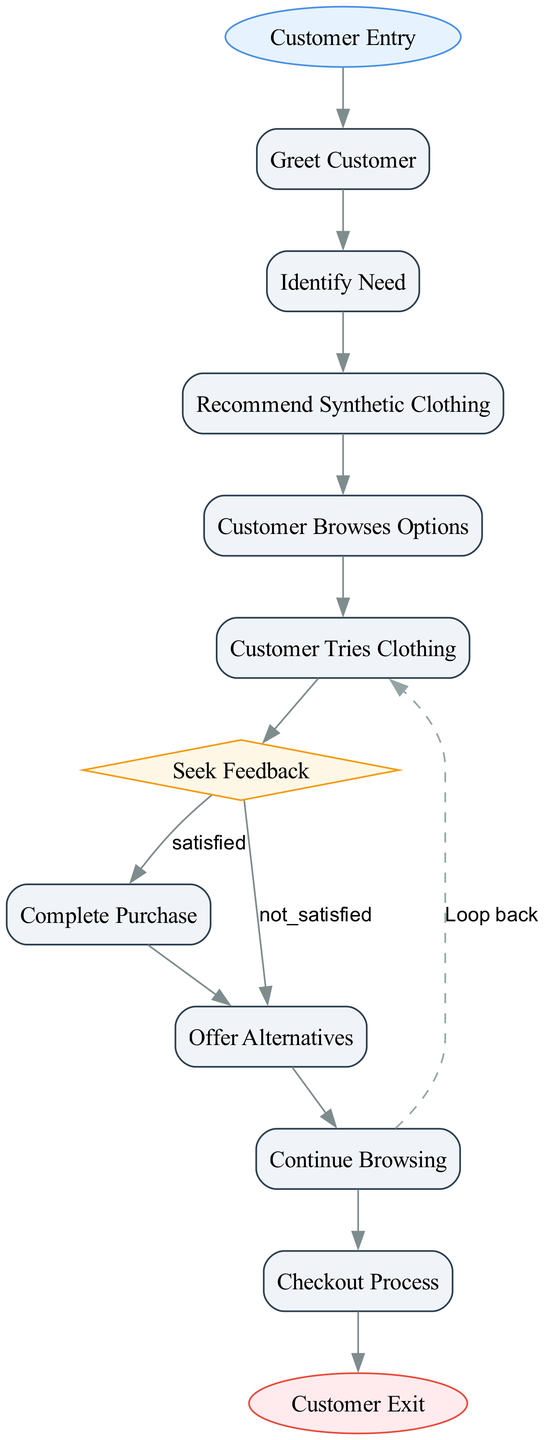What is the starting point of this customer purchase experience? The starting point is the "Customer Entry" where the customer enters the retail store.
Answer: Customer Entry How many decision nodes are in the diagram? There is one decision node, which is "Seek Feedback" that determines if the customer is satisfied or not.
Answer: 1 What does the "Offer Alternatives" node represent? The "Offer Alternatives" node represents the process where the customer service representative suggests alternative synthetic clothing items based on the feedback received.
Answer: Suggest alternatives What happens if the customer is satisfied after trying clothing? If the customer is satisfied, they proceed to "Complete Purchase" which is the next step in the flowchart after the decision of satisfaction.
Answer: Complete Purchase What steps occur after "Customer Tries Clothing"? After "Customer Tries Clothing", the next step is "Seek Feedback" where the customer service representative seeks feedback on the items tried.
Answer: Seek Feedback What is the final step in the flow chart? The final step in the flowchart is "Customer Exit", which indicates that the customer leaves the store with their purchase after assistance ends.
Answer: Customer Exit What is the relationship between "Seek Feedback" and "Complete Purchase"? The relationship is based on the customer's satisfaction; if the feedback is positive, it leads to "Complete Purchase".
Answer: Satisfaction leads to purchase How does "Continue Browsing" relate to "Offer Alternatives"? "Continue Browsing" is a process where the customer examines other options suggested in "Offer Alternatives" until they find something satisfactory.
Answer: Browsing for alternatives What do customers do at the "Checkout Process" node? At the "Checkout Process" node, customers finalize and pay for their purchase at the checkout counter.
Answer: Finalize purchase 